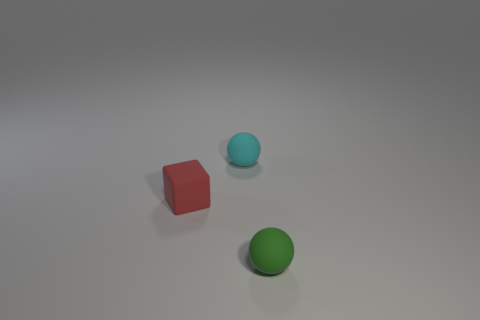Add 3 red rubber blocks. How many objects exist? 6 Subtract all spheres. How many objects are left? 1 Subtract 1 cubes. How many cubes are left? 0 Subtract all cyan balls. How many balls are left? 1 Subtract all brown spheres. Subtract all red cylinders. How many spheres are left? 2 Subtract all red matte things. Subtract all small red blocks. How many objects are left? 1 Add 2 tiny matte things. How many tiny matte things are left? 5 Add 1 small rubber blocks. How many small rubber blocks exist? 2 Subtract 0 gray spheres. How many objects are left? 3 